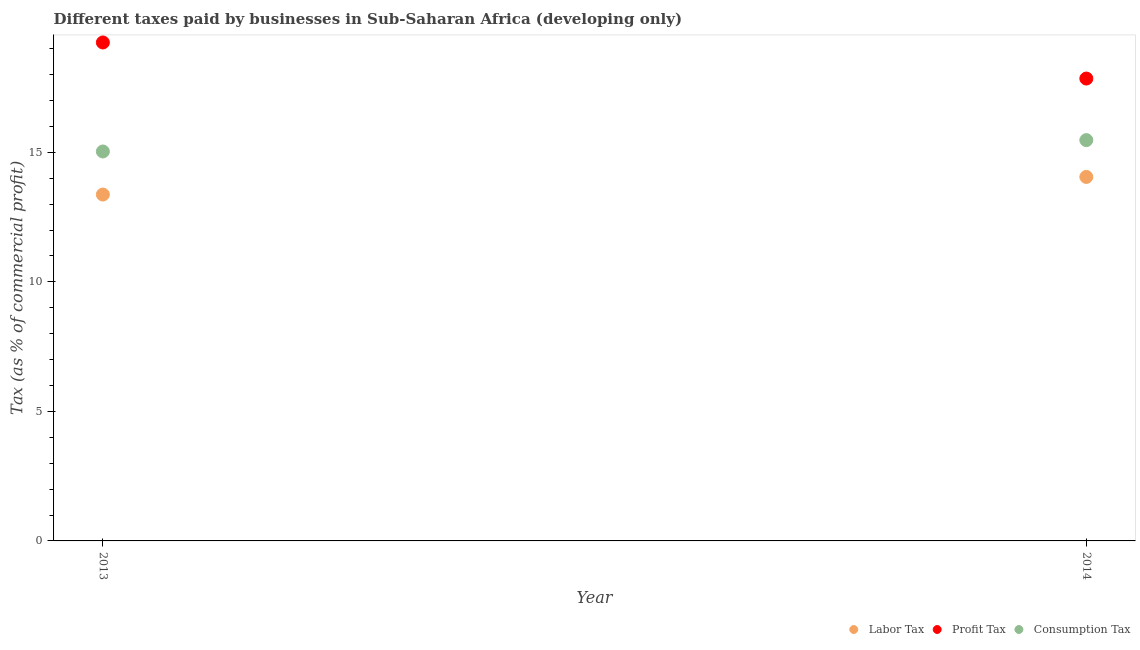How many different coloured dotlines are there?
Ensure brevity in your answer.  3. Is the number of dotlines equal to the number of legend labels?
Provide a short and direct response. Yes. What is the percentage of profit tax in 2014?
Ensure brevity in your answer.  17.85. Across all years, what is the maximum percentage of labor tax?
Ensure brevity in your answer.  14.05. Across all years, what is the minimum percentage of labor tax?
Keep it short and to the point. 13.37. In which year was the percentage of profit tax maximum?
Your response must be concise. 2013. What is the total percentage of consumption tax in the graph?
Keep it short and to the point. 30.5. What is the difference between the percentage of profit tax in 2013 and that in 2014?
Your response must be concise. 1.39. What is the difference between the percentage of labor tax in 2014 and the percentage of consumption tax in 2013?
Your answer should be very brief. -0.98. What is the average percentage of profit tax per year?
Your answer should be compact. 18.54. In the year 2014, what is the difference between the percentage of profit tax and percentage of consumption tax?
Your answer should be very brief. 2.38. What is the ratio of the percentage of consumption tax in 2013 to that in 2014?
Keep it short and to the point. 0.97. In how many years, is the percentage of labor tax greater than the average percentage of labor tax taken over all years?
Your answer should be very brief. 1. Is it the case that in every year, the sum of the percentage of labor tax and percentage of profit tax is greater than the percentage of consumption tax?
Your answer should be compact. Yes. Is the percentage of consumption tax strictly greater than the percentage of profit tax over the years?
Your answer should be compact. No. Is the percentage of labor tax strictly less than the percentage of profit tax over the years?
Ensure brevity in your answer.  Yes. How many dotlines are there?
Your answer should be compact. 3. What is the difference between two consecutive major ticks on the Y-axis?
Your answer should be compact. 5. Does the graph contain any zero values?
Your answer should be compact. No. Does the graph contain grids?
Provide a succinct answer. No. Where does the legend appear in the graph?
Provide a succinct answer. Bottom right. What is the title of the graph?
Your answer should be very brief. Different taxes paid by businesses in Sub-Saharan Africa (developing only). What is the label or title of the Y-axis?
Your answer should be very brief. Tax (as % of commercial profit). What is the Tax (as % of commercial profit) in Labor Tax in 2013?
Provide a short and direct response. 13.37. What is the Tax (as % of commercial profit) of Profit Tax in 2013?
Ensure brevity in your answer.  19.24. What is the Tax (as % of commercial profit) in Consumption Tax in 2013?
Give a very brief answer. 15.03. What is the Tax (as % of commercial profit) in Labor Tax in 2014?
Offer a terse response. 14.05. What is the Tax (as % of commercial profit) of Profit Tax in 2014?
Ensure brevity in your answer.  17.85. What is the Tax (as % of commercial profit) of Consumption Tax in 2014?
Provide a short and direct response. 15.47. Across all years, what is the maximum Tax (as % of commercial profit) in Labor Tax?
Provide a succinct answer. 14.05. Across all years, what is the maximum Tax (as % of commercial profit) in Profit Tax?
Give a very brief answer. 19.24. Across all years, what is the maximum Tax (as % of commercial profit) in Consumption Tax?
Offer a very short reply. 15.47. Across all years, what is the minimum Tax (as % of commercial profit) in Labor Tax?
Keep it short and to the point. 13.37. Across all years, what is the minimum Tax (as % of commercial profit) in Profit Tax?
Your answer should be very brief. 17.85. Across all years, what is the minimum Tax (as % of commercial profit) in Consumption Tax?
Your answer should be compact. 15.03. What is the total Tax (as % of commercial profit) in Labor Tax in the graph?
Keep it short and to the point. 27.42. What is the total Tax (as % of commercial profit) of Profit Tax in the graph?
Your answer should be compact. 37.09. What is the total Tax (as % of commercial profit) in Consumption Tax in the graph?
Offer a very short reply. 30.5. What is the difference between the Tax (as % of commercial profit) of Labor Tax in 2013 and that in 2014?
Provide a succinct answer. -0.68. What is the difference between the Tax (as % of commercial profit) of Profit Tax in 2013 and that in 2014?
Your answer should be compact. 1.39. What is the difference between the Tax (as % of commercial profit) in Consumption Tax in 2013 and that in 2014?
Offer a very short reply. -0.44. What is the difference between the Tax (as % of commercial profit) of Labor Tax in 2013 and the Tax (as % of commercial profit) of Profit Tax in 2014?
Keep it short and to the point. -4.48. What is the difference between the Tax (as % of commercial profit) in Labor Tax in 2013 and the Tax (as % of commercial profit) in Consumption Tax in 2014?
Keep it short and to the point. -2.1. What is the difference between the Tax (as % of commercial profit) in Profit Tax in 2013 and the Tax (as % of commercial profit) in Consumption Tax in 2014?
Make the answer very short. 3.77. What is the average Tax (as % of commercial profit) of Labor Tax per year?
Your answer should be compact. 13.71. What is the average Tax (as % of commercial profit) of Profit Tax per year?
Your response must be concise. 18.54. What is the average Tax (as % of commercial profit) in Consumption Tax per year?
Keep it short and to the point. 15.25. In the year 2013, what is the difference between the Tax (as % of commercial profit) of Labor Tax and Tax (as % of commercial profit) of Profit Tax?
Ensure brevity in your answer.  -5.87. In the year 2013, what is the difference between the Tax (as % of commercial profit) in Labor Tax and Tax (as % of commercial profit) in Consumption Tax?
Your answer should be compact. -1.66. In the year 2013, what is the difference between the Tax (as % of commercial profit) of Profit Tax and Tax (as % of commercial profit) of Consumption Tax?
Keep it short and to the point. 4.21. In the year 2014, what is the difference between the Tax (as % of commercial profit) of Labor Tax and Tax (as % of commercial profit) of Profit Tax?
Keep it short and to the point. -3.8. In the year 2014, what is the difference between the Tax (as % of commercial profit) of Labor Tax and Tax (as % of commercial profit) of Consumption Tax?
Make the answer very short. -1.42. In the year 2014, what is the difference between the Tax (as % of commercial profit) in Profit Tax and Tax (as % of commercial profit) in Consumption Tax?
Offer a terse response. 2.38. What is the ratio of the Tax (as % of commercial profit) of Labor Tax in 2013 to that in 2014?
Your answer should be compact. 0.95. What is the ratio of the Tax (as % of commercial profit) in Profit Tax in 2013 to that in 2014?
Make the answer very short. 1.08. What is the ratio of the Tax (as % of commercial profit) in Consumption Tax in 2013 to that in 2014?
Your response must be concise. 0.97. What is the difference between the highest and the second highest Tax (as % of commercial profit) in Labor Tax?
Keep it short and to the point. 0.68. What is the difference between the highest and the second highest Tax (as % of commercial profit) in Profit Tax?
Your answer should be very brief. 1.39. What is the difference between the highest and the second highest Tax (as % of commercial profit) in Consumption Tax?
Keep it short and to the point. 0.44. What is the difference between the highest and the lowest Tax (as % of commercial profit) in Labor Tax?
Provide a short and direct response. 0.68. What is the difference between the highest and the lowest Tax (as % of commercial profit) of Profit Tax?
Your response must be concise. 1.39. What is the difference between the highest and the lowest Tax (as % of commercial profit) of Consumption Tax?
Offer a terse response. 0.44. 